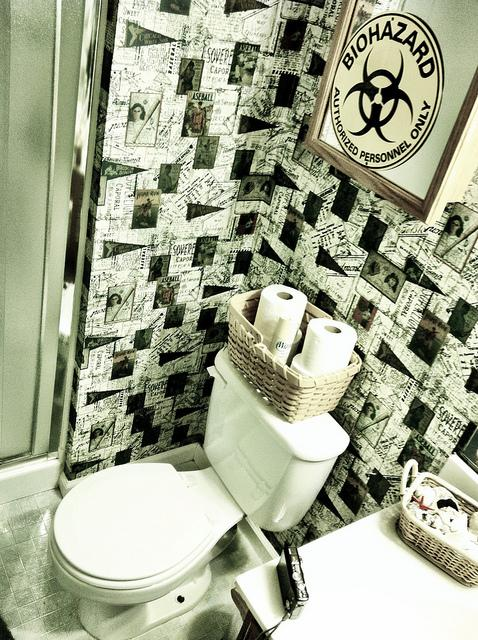What does the sign say? Please explain your reasoning. biohazard. A biohazard sign is in a bathroom. 